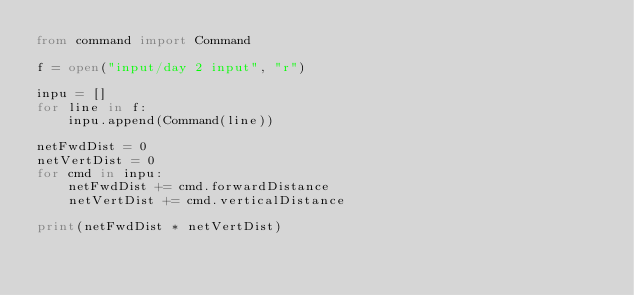<code> <loc_0><loc_0><loc_500><loc_500><_Python_>from command import Command

f = open("input/day 2 input", "r")

inpu = []
for line in f:
    inpu.append(Command(line))

netFwdDist = 0
netVertDist = 0
for cmd in inpu:
    netFwdDist += cmd.forwardDistance
    netVertDist += cmd.verticalDistance

print(netFwdDist * netVertDist)</code> 